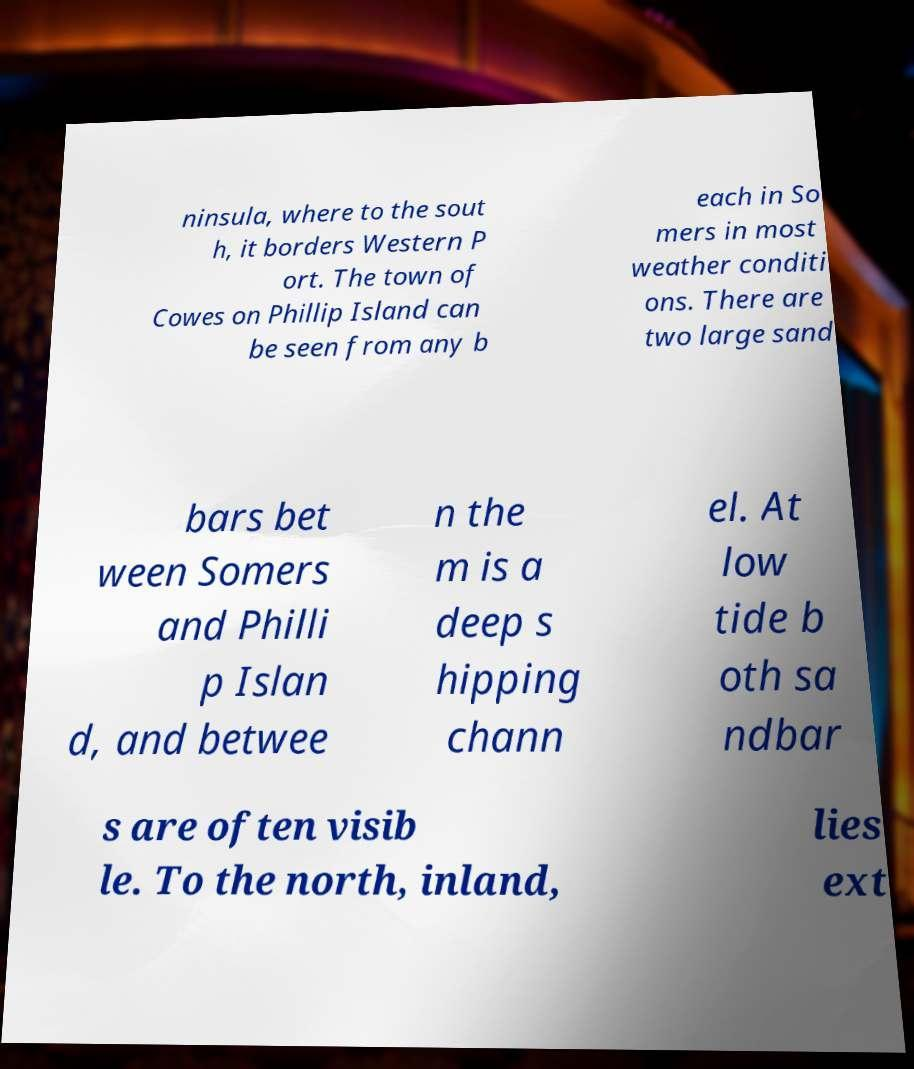Can you read and provide the text displayed in the image?This photo seems to have some interesting text. Can you extract and type it out for me? ninsula, where to the sout h, it borders Western P ort. The town of Cowes on Phillip Island can be seen from any b each in So mers in most weather conditi ons. There are two large sand bars bet ween Somers and Philli p Islan d, and betwee n the m is a deep s hipping chann el. At low tide b oth sa ndbar s are often visib le. To the north, inland, lies ext 